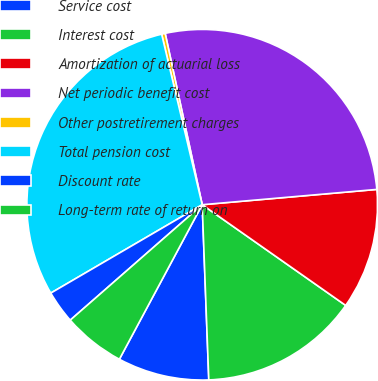<chart> <loc_0><loc_0><loc_500><loc_500><pie_chart><fcel>Service cost<fcel>Interest cost<fcel>Amortization of actuarial loss<fcel>Net periodic benefit cost<fcel>Other postretirement charges<fcel>Total pension cost<fcel>Discount rate<fcel>Long-term rate of return on<nl><fcel>8.43%<fcel>14.66%<fcel>11.13%<fcel>26.99%<fcel>0.33%<fcel>29.69%<fcel>3.03%<fcel>5.73%<nl></chart> 